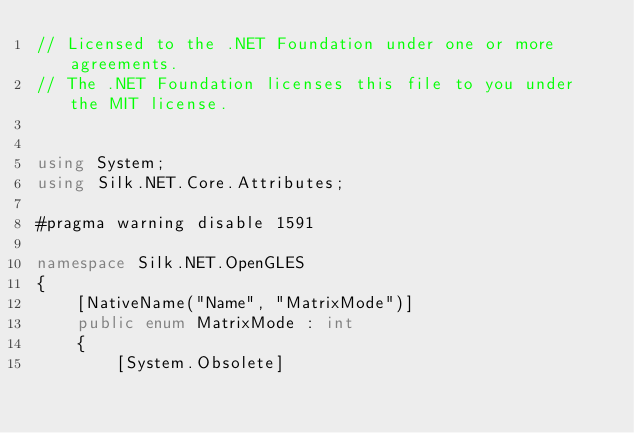Convert code to text. <code><loc_0><loc_0><loc_500><loc_500><_C#_>// Licensed to the .NET Foundation under one or more agreements.
// The .NET Foundation licenses this file to you under the MIT license.


using System;
using Silk.NET.Core.Attributes;

#pragma warning disable 1591

namespace Silk.NET.OpenGLES
{
    [NativeName("Name", "MatrixMode")]
    public enum MatrixMode : int
    {
        [System.Obsolete]</code> 